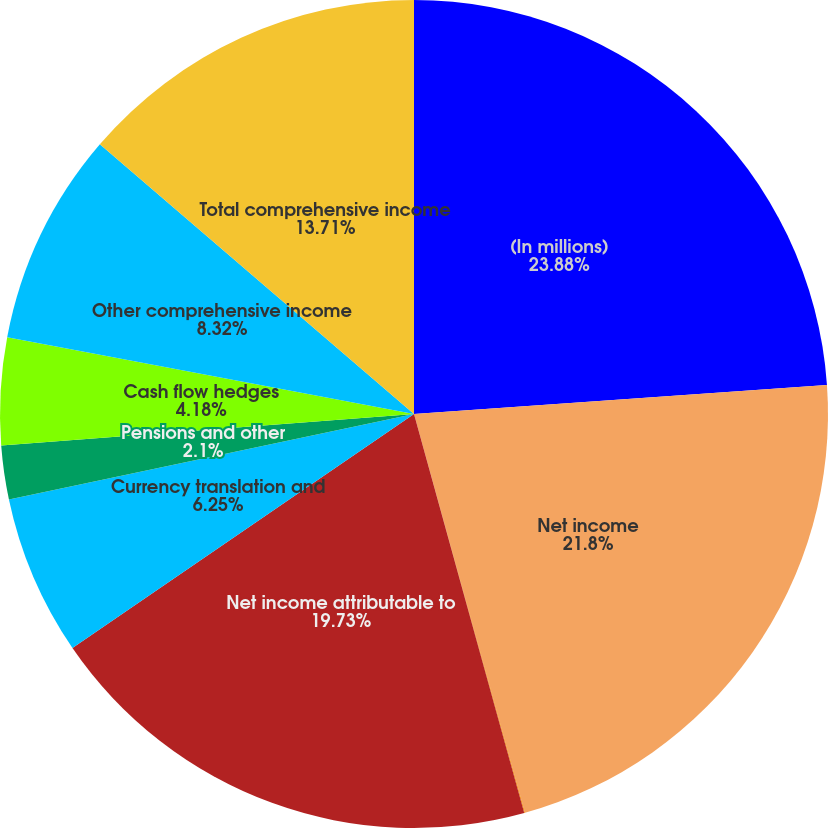Convert chart to OTSL. <chart><loc_0><loc_0><loc_500><loc_500><pie_chart><fcel>(In millions)<fcel>Net income<fcel>Less net income for<fcel>Net income attributable to<fcel>Currency translation and<fcel>Pensions and other<fcel>Cash flow hedges<fcel>Other comprehensive income<fcel>Total comprehensive income<nl><fcel>23.88%<fcel>21.8%<fcel>0.03%<fcel>19.73%<fcel>6.25%<fcel>2.1%<fcel>4.18%<fcel>8.32%<fcel>13.71%<nl></chart> 